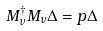<formula> <loc_0><loc_0><loc_500><loc_500>M _ { \nu } ^ { \dagger } M _ { \nu } \Delta = p \Delta</formula> 